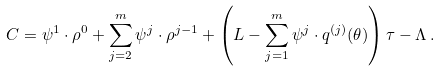Convert formula to latex. <formula><loc_0><loc_0><loc_500><loc_500>C = \psi ^ { 1 } \cdot \rho ^ { 0 } + \sum _ { j = 2 } ^ { m } \psi ^ { j } \cdot \rho ^ { j - 1 } + \left ( L - \sum _ { j = 1 } ^ { m } \psi ^ { j } \cdot q ^ { ( j ) } ( \theta ) \right ) \tau - \Lambda \, .</formula> 